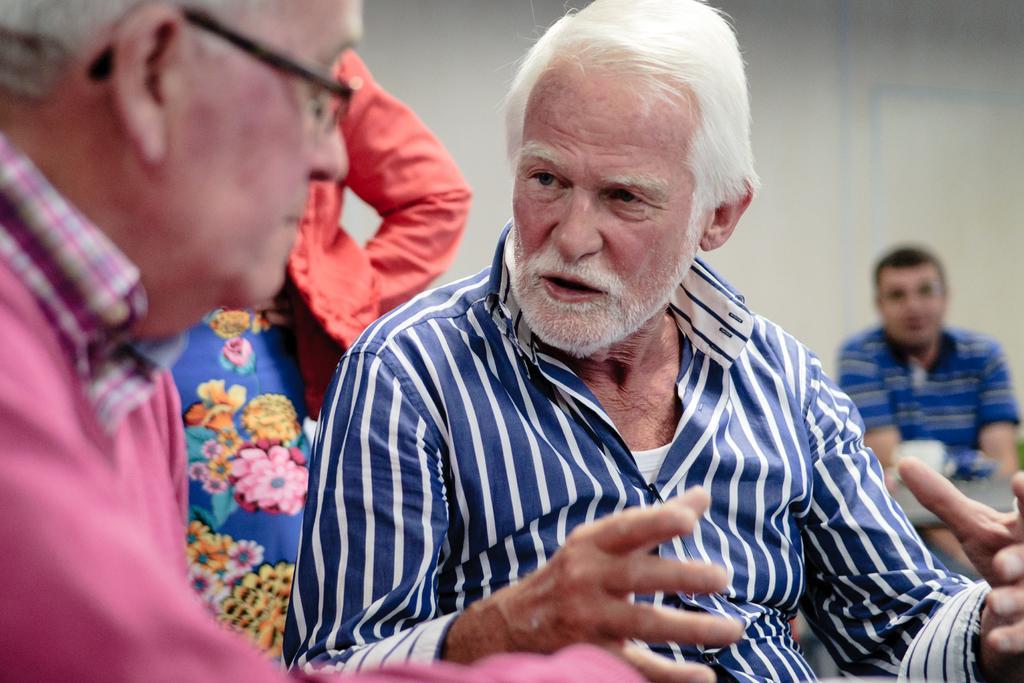How would you summarize this image in a sentence or two? As we can see in the image there is a wall and few people here and there. 